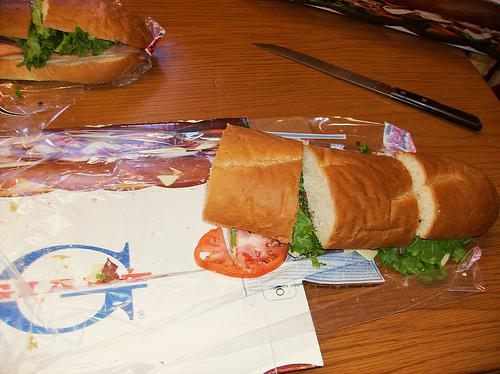Question: what type of food is shown?
Choices:
A. Steak.
B. Pork chop.
C. Fried chicken.
D. A sandwich.
Answer with the letter. Answer: D Question: what material is the table?
Choices:
A. Plastic.
B. Metal.
C. Glass.
D. Wood.
Answer with the letter. Answer: D Question: what red food is shown?
Choices:
A. Spaghetti sauce.
B. Tobasco sauce.
C. Tomato.
D. Strawberry jam.
Answer with the letter. Answer: C Question: what kind of utensil is shown?
Choices:
A. Knife.
B. Wisk.
C. Cleaver.
D. Can opener.
Answer with the letter. Answer: A Question: where is the sandwich?
Choices:
A. Trash.
B. On the table.
C. On a plate.
D. On a napkin.
Answer with the letter. Answer: B Question: what green food is shown?
Choices:
A. Kiwi.
B. Tomato.
C. Lettuce.
D. Kale.
Answer with the letter. Answer: C 